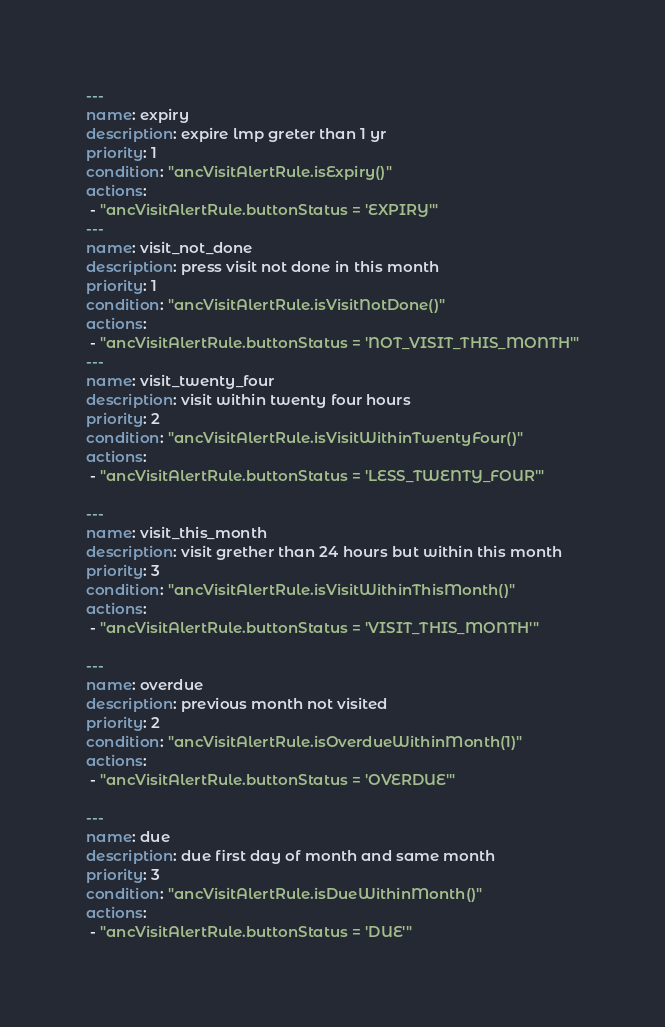Convert code to text. <code><loc_0><loc_0><loc_500><loc_500><_YAML_>---
name: expiry
description: expire lmp greter than 1 yr
priority: 1
condition: "ancVisitAlertRule.isExpiry()"
actions:
 - "ancVisitAlertRule.buttonStatus = 'EXPIRY'"
---
name: visit_not_done
description: press visit not done in this month
priority: 1
condition: "ancVisitAlertRule.isVisitNotDone()"
actions:
 - "ancVisitAlertRule.buttonStatus = 'NOT_VISIT_THIS_MONTH'"
---
name: visit_twenty_four
description: visit within twenty four hours
priority: 2
condition: "ancVisitAlertRule.isVisitWithinTwentyFour()"
actions:
 - "ancVisitAlertRule.buttonStatus = 'LESS_TWENTY_FOUR'"

---
name: visit_this_month
description: visit grether than 24 hours but within this month
priority: 3
condition: "ancVisitAlertRule.isVisitWithinThisMonth()"
actions:
 - "ancVisitAlertRule.buttonStatus = 'VISIT_THIS_MONTH'"

---
name: overdue
description: previous month not visited
priority: 2
condition: "ancVisitAlertRule.isOverdueWithinMonth(1)"
actions:
 - "ancVisitAlertRule.buttonStatus = 'OVERDUE'"

---
name: due
description: due first day of month and same month
priority: 3
condition: "ancVisitAlertRule.isDueWithinMonth()"
actions:
 - "ancVisitAlertRule.buttonStatus = 'DUE'"

</code> 